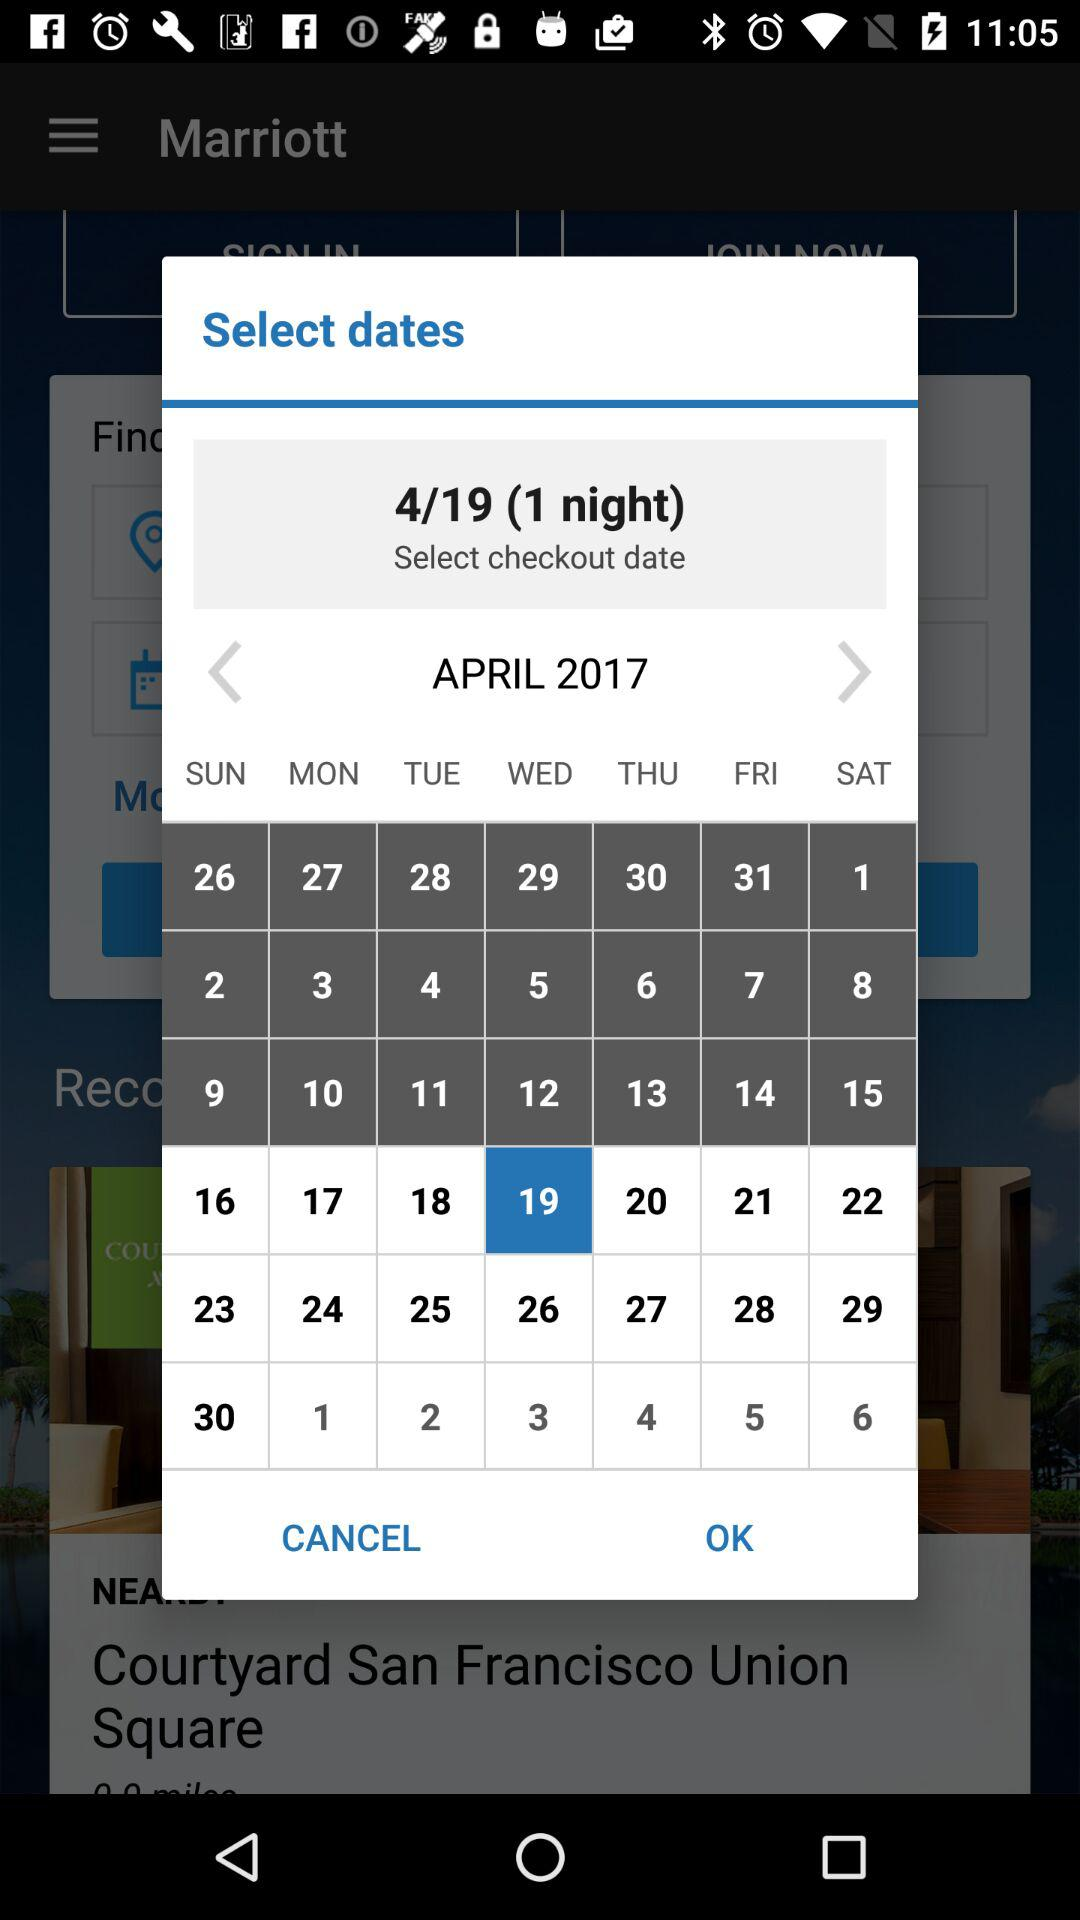What date is marked in the calendar? The marked date in the calendar is Wednesday, April 19, 2017. 